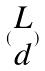Convert formula to latex. <formula><loc_0><loc_0><loc_500><loc_500>( \begin{matrix} L \\ d \end{matrix} )</formula> 